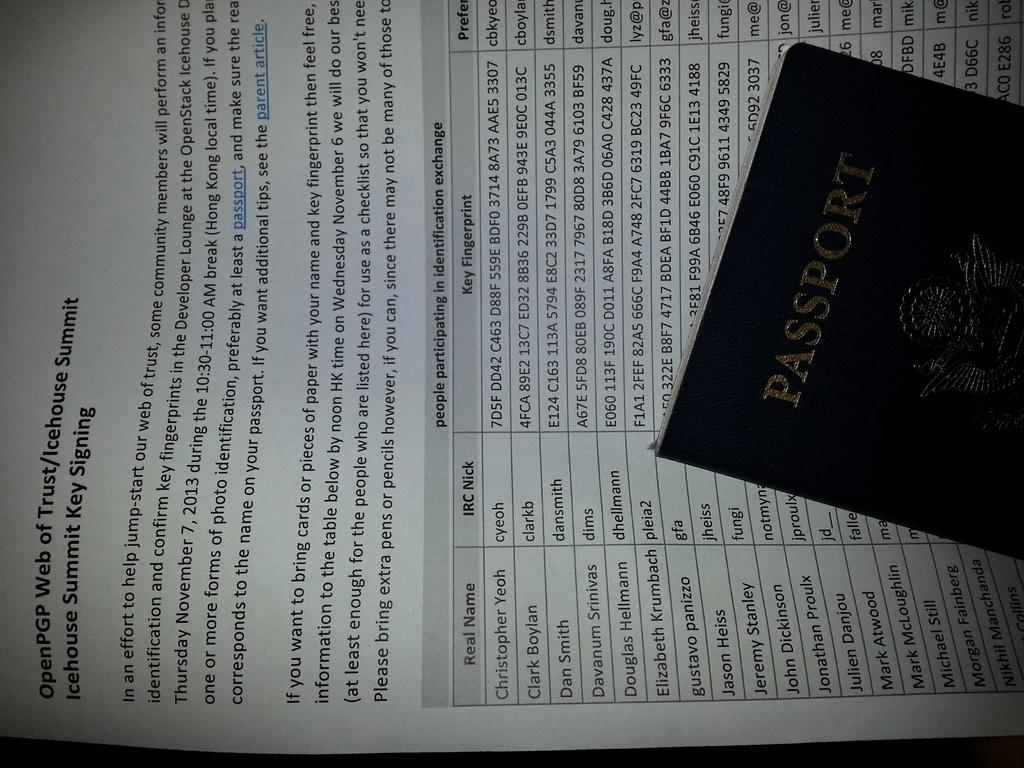<image>
Provide a brief description of the given image. A passport lays on top of a piece of paper about a summit. 